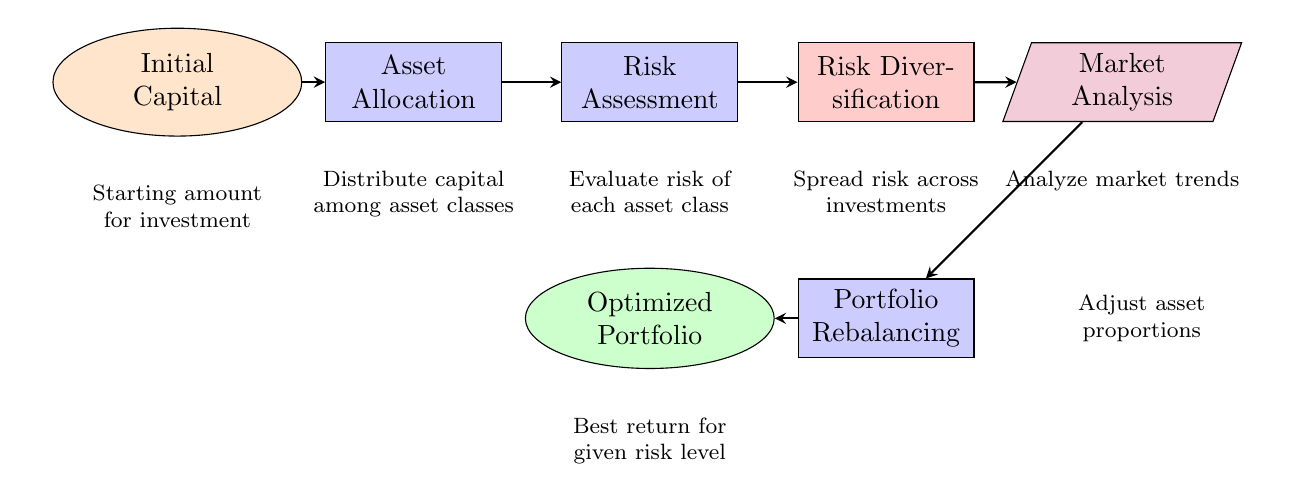What is the starting amount for investment? The starting amount is labeled in the "Initial Capital" node, which is the first step in the diagram.
Answer: Initial Capital What comes after Asset Allocation? Following the "Asset Allocation" node, the next node is "Risk Assessment," indicating the sequence of steps in the process.
Answer: Risk Assessment How many nodes are present in the diagram? By counting all distinct blocks in the diagram (including sources, sinks, and nodes), there are seven nodes in total.
Answer: Seven What is the final outcome of this investment process? The outcome is represented in the "Optimized Portfolio" sink, which is the last step in the diagram, indicating the goal of the investment strategy.
Answer: Optimized Portfolio What element is responsible for spreading risk across investments? The "Risk Diversification" component is specifically designated to address the spreading of risk across various investments according to the diagram’s flow.
Answer: Risk Diversification Which node is directly linked to Market Analysis? The node that feeds into "Market Analysis" is "Risk Diversification," making it the preceding step in the decision-making process.
Answer: Risk Diversification What is the purpose of Portfolio Rebalancing? The "Portfolio Rebalancing" node represents the adjustment of asset proportions to maintain the desired risk-return trade-off throughout the investment process.
Answer: Adjust asset proportions Which two nodes are connected to the Risk Diversification node? The "Risk Assessment" node feeds directly into "Risk Diversification," and "Market Analysis" is a subsequent node, indicating a flow of decisions.
Answer: Risk Assessment and Market Analysis What kind of analysis is performed after Risk Assessment? The diagram indicates that "Market Analysis" follows the "Risk Assessment," showing it is the subsequent analysis to be conducted.
Answer: Market Analysis 